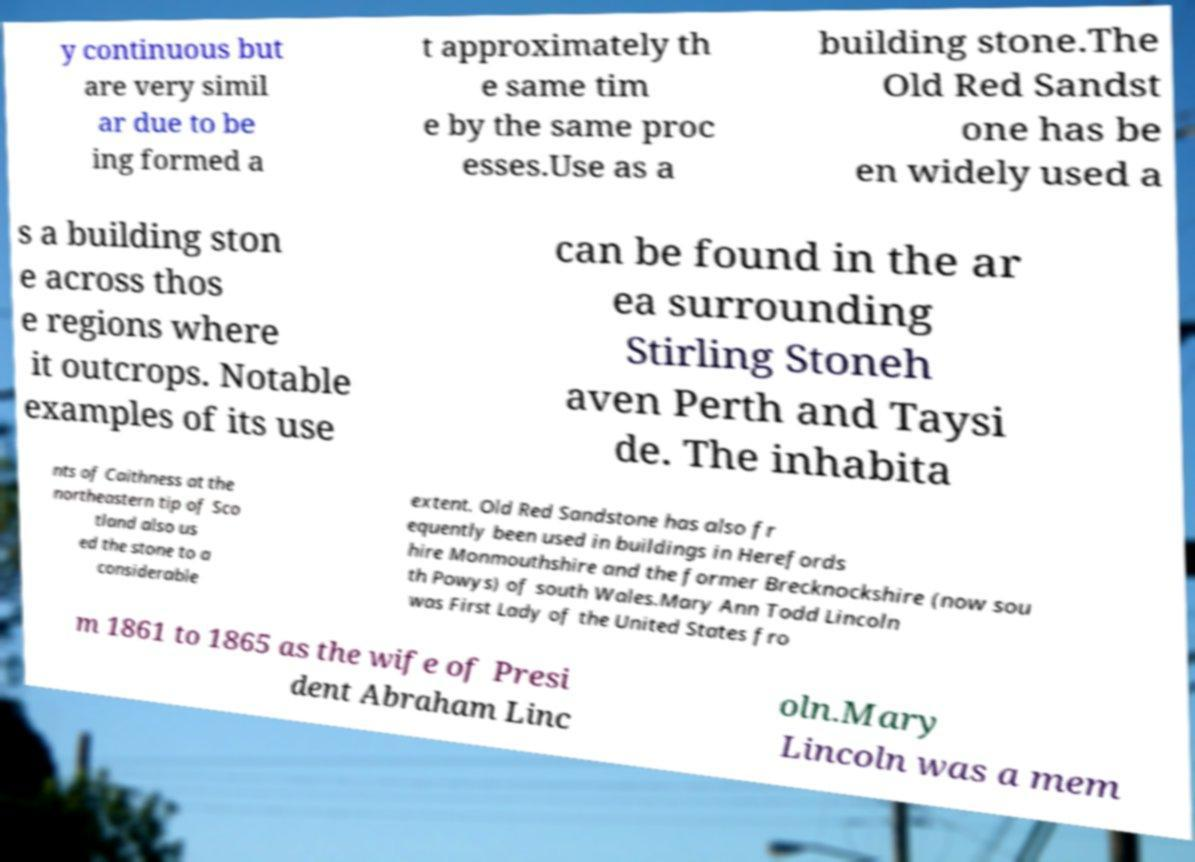There's text embedded in this image that I need extracted. Can you transcribe it verbatim? y continuous but are very simil ar due to be ing formed a t approximately th e same tim e by the same proc esses.Use as a building stone.The Old Red Sandst one has be en widely used a s a building ston e across thos e regions where it outcrops. Notable examples of its use can be found in the ar ea surrounding Stirling Stoneh aven Perth and Taysi de. The inhabita nts of Caithness at the northeastern tip of Sco tland also us ed the stone to a considerable extent. Old Red Sandstone has also fr equently been used in buildings in Herefords hire Monmouthshire and the former Brecknockshire (now sou th Powys) of south Wales.Mary Ann Todd Lincoln was First Lady of the United States fro m 1861 to 1865 as the wife of Presi dent Abraham Linc oln.Mary Lincoln was a mem 